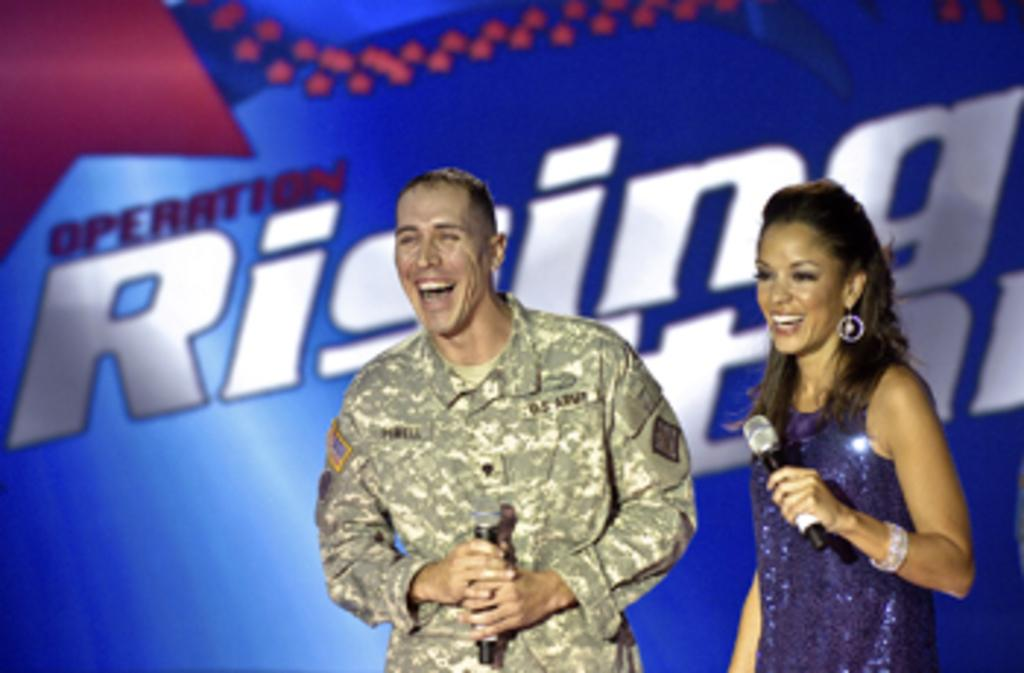How many people are present in the image? There are two people, a man and a woman, present in the image. What are the man and the woman holding in their hands? Both the man and the woman are holding a mic in their hands. What is the emotional state of the man and the woman in the image? The man and the woman are laughing in the image. What can be seen in the background of the image? There is some text visible in the background of the image, and the background is in blue color. Can you tell me how many cacti are present in the image? There are no cacti present in the image. What type of pleasure can be seen being experienced by the man and the woman in the image? The image does not show any specific type of pleasure being experienced by the man and the woman; they are simply laughing. 